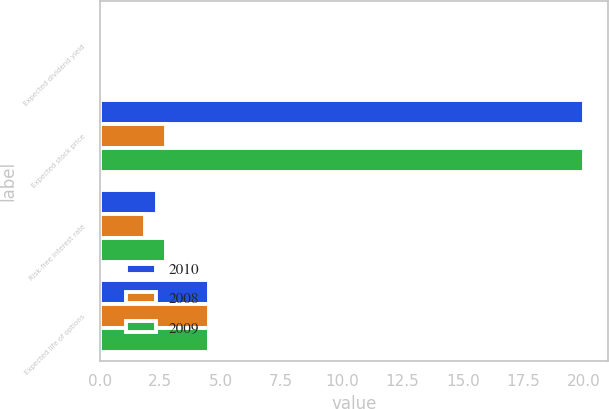Convert chart to OTSL. <chart><loc_0><loc_0><loc_500><loc_500><stacked_bar_chart><ecel><fcel>Expected dividend yield<fcel>Expected stock price<fcel>Risk-free interest rate<fcel>Expected life of options<nl><fcel>2010<fcel>0<fcel>20<fcel>2.37<fcel>4.5<nl><fcel>2008<fcel>0<fcel>2.75<fcel>1.88<fcel>4.5<nl><fcel>2009<fcel>0<fcel>20<fcel>2.75<fcel>4.5<nl></chart> 